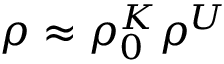Convert formula to latex. <formula><loc_0><loc_0><loc_500><loc_500>\rho \approx \rho _ { 0 } ^ { K } \rho ^ { U }</formula> 